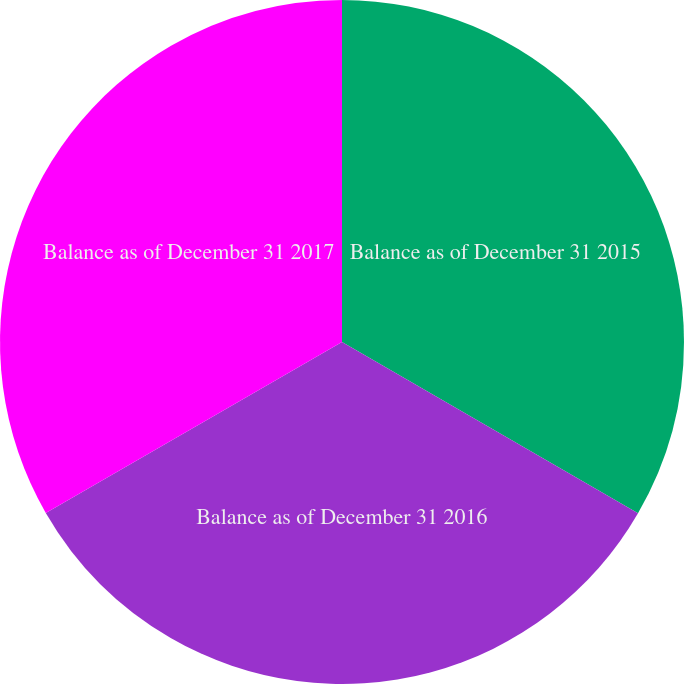Convert chart to OTSL. <chart><loc_0><loc_0><loc_500><loc_500><pie_chart><fcel>Balance as of December 31 2015<fcel>Balance as of December 31 2016<fcel>Balance as of December 31 2017<nl><fcel>33.35%<fcel>33.32%<fcel>33.33%<nl></chart> 